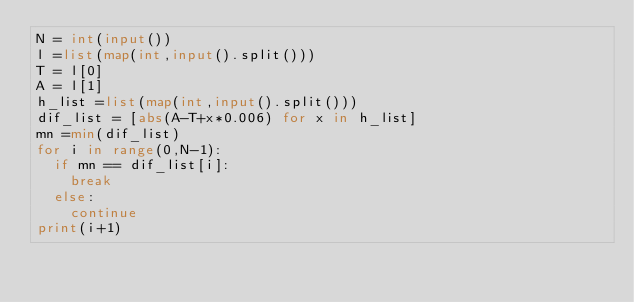<code> <loc_0><loc_0><loc_500><loc_500><_Python_>N = int(input())
l =list(map(int,input().split()))
T = l[0]
A = l[1]
h_list =list(map(int,input().split()))
dif_list = [abs(A-T+x*0.006) for x in h_list]
mn =min(dif_list)
for i in range(0,N-1):
	if mn == dif_list[i]:
		break
	else:
		continue
print(i+1)</code> 